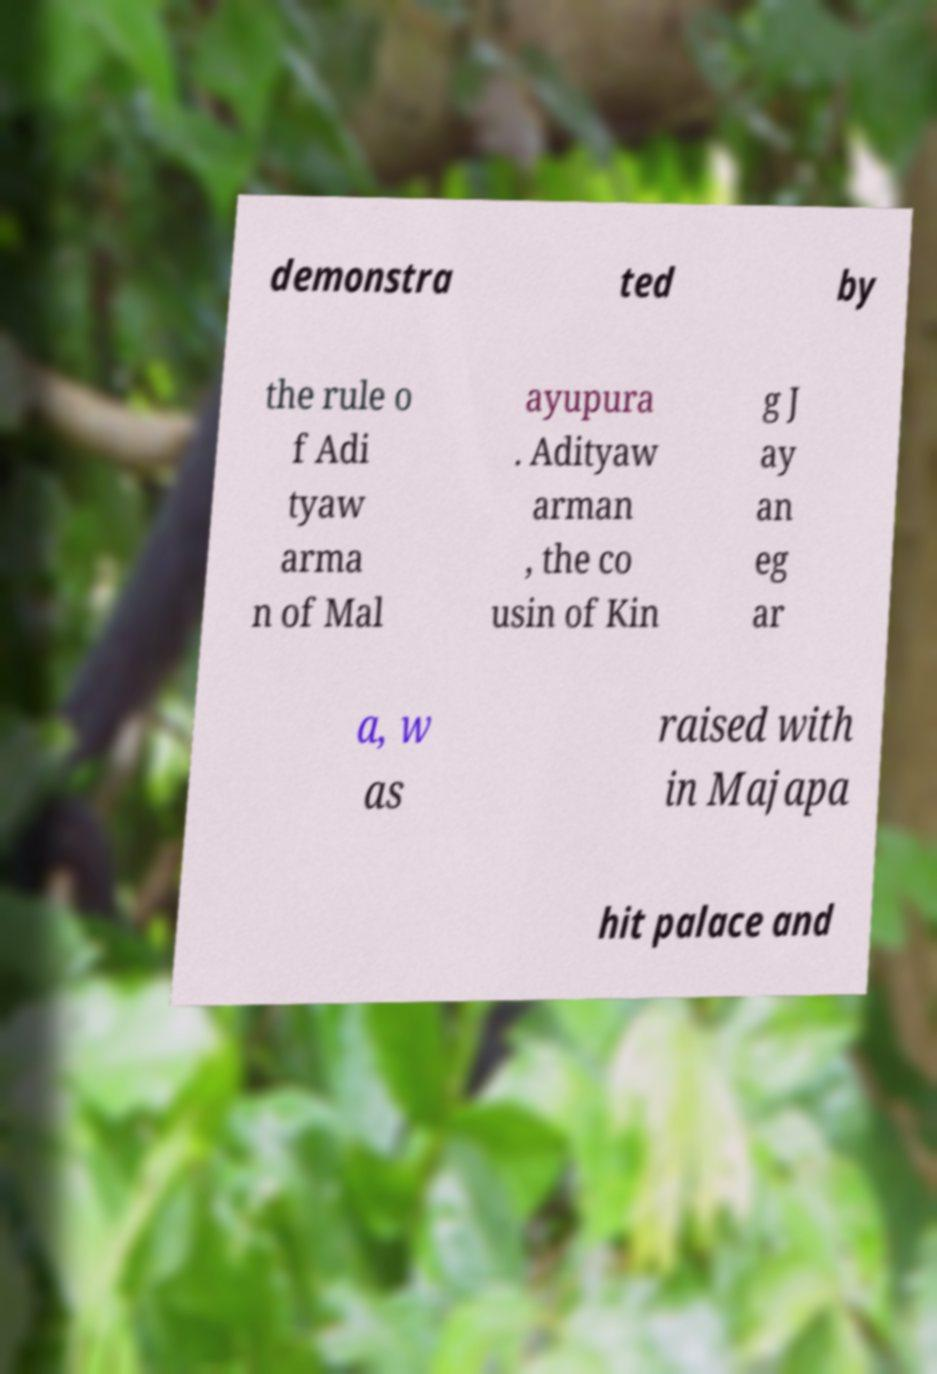For documentation purposes, I need the text within this image transcribed. Could you provide that? demonstra ted by the rule o f Adi tyaw arma n of Mal ayupura . Adityaw arman , the co usin of Kin g J ay an eg ar a, w as raised with in Majapa hit palace and 